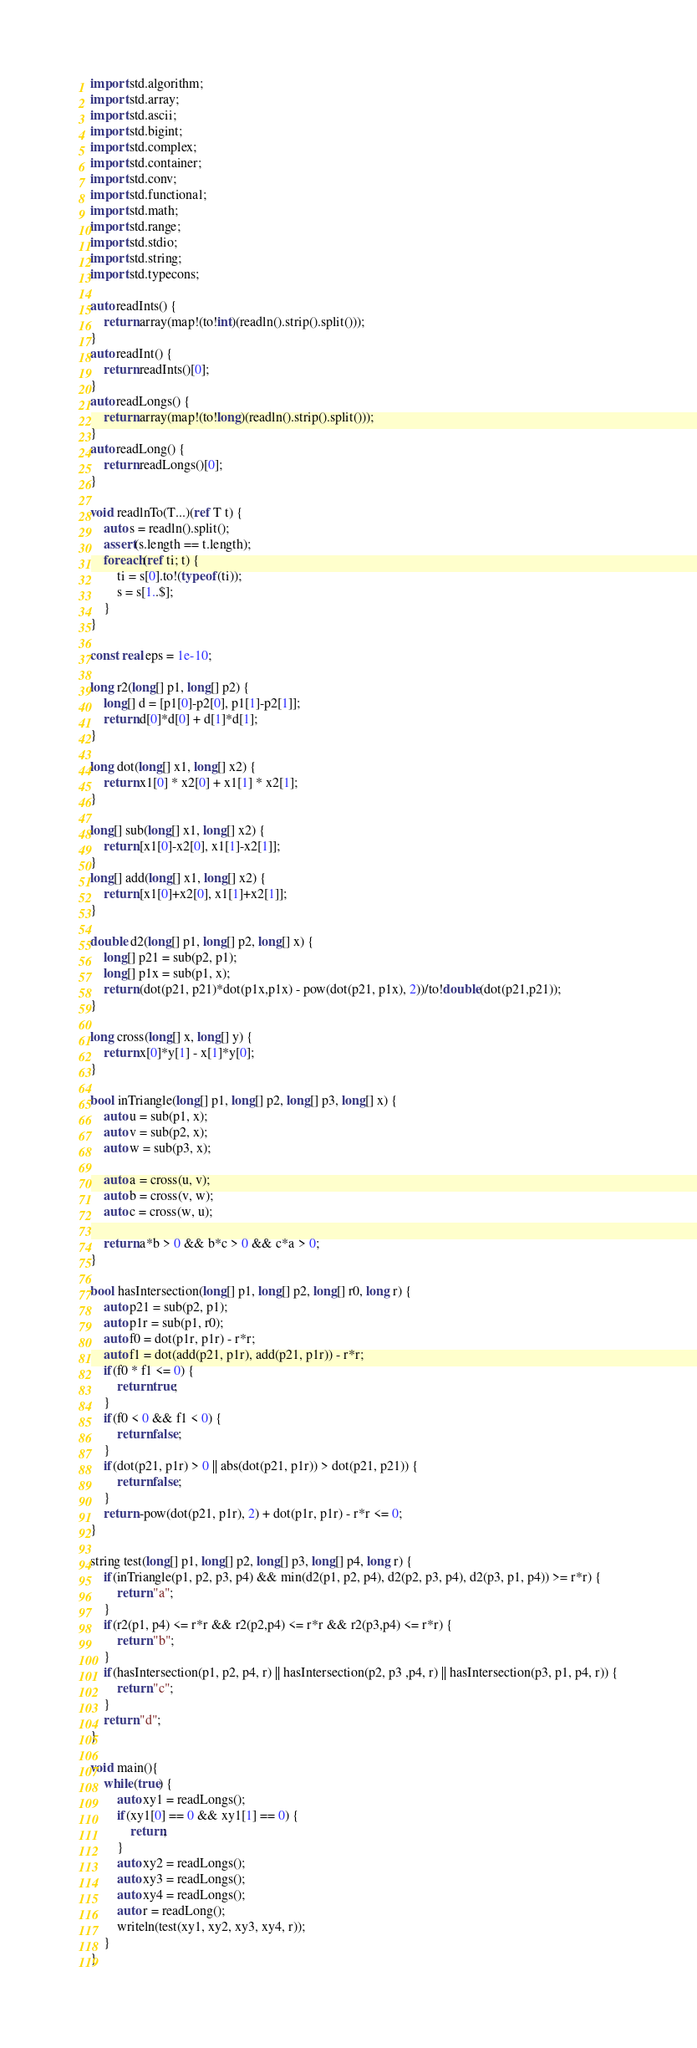Convert code to text. <code><loc_0><loc_0><loc_500><loc_500><_D_>import std.algorithm;
import std.array;
import std.ascii;
import std.bigint;
import std.complex;
import std.container;
import std.conv;
import std.functional;
import std.math;
import std.range;
import std.stdio;
import std.string;
import std.typecons;

auto readInts() {
	return array(map!(to!int)(readln().strip().split()));
}
auto readInt() {
	return readInts()[0];
}
auto readLongs() {
	return array(map!(to!long)(readln().strip().split()));
}
auto readLong() {
	return readLongs()[0];
}

void readlnTo(T...)(ref T t) {
    auto s = readln().split();
    assert(s.length == t.length);
    foreach(ref ti; t) {
        ti = s[0].to!(typeof(ti));
        s = s[1..$];
    }
}

const real eps = 1e-10;

long r2(long[] p1, long[] p2) {
    long[] d = [p1[0]-p2[0], p1[1]-p2[1]];
    return d[0]*d[0] + d[1]*d[1];
}

long dot(long[] x1, long[] x2) {
    return x1[0] * x2[0] + x1[1] * x2[1];
}

long[] sub(long[] x1, long[] x2) {
    return [x1[0]-x2[0], x1[1]-x2[1]];
}
long[] add(long[] x1, long[] x2) {
    return [x1[0]+x2[0], x1[1]+x2[1]];
}

double d2(long[] p1, long[] p2, long[] x) {
    long[] p21 = sub(p2, p1);
    long[] p1x = sub(p1, x);
    return (dot(p21, p21)*dot(p1x,p1x) - pow(dot(p21, p1x), 2))/to!double(dot(p21,p21));
}

long cross(long[] x, long[] y) {
    return x[0]*y[1] - x[1]*y[0];
}

bool inTriangle(long[] p1, long[] p2, long[] p3, long[] x) {
    auto u = sub(p1, x);
    auto v = sub(p2, x);
    auto w = sub(p3, x);
    
    auto a = cross(u, v);
    auto b = cross(v, w);
    auto c = cross(w, u);

    return a*b > 0 && b*c > 0 && c*a > 0;
}

bool hasIntersection(long[] p1, long[] p2, long[] r0, long r) {
    auto p21 = sub(p2, p1);
    auto p1r = sub(p1, r0);
    auto f0 = dot(p1r, p1r) - r*r;
    auto f1 = dot(add(p21, p1r), add(p21, p1r)) - r*r;
    if(f0 * f1 <= 0) {
        return true;
    }
    if(f0 < 0 && f1 < 0) {
        return false;
    }
    if(dot(p21, p1r) > 0 || abs(dot(p21, p1r)) > dot(p21, p21)) {
        return false;
    }
    return -pow(dot(p21, p1r), 2) + dot(p1r, p1r) - r*r <= 0;
}

string test(long[] p1, long[] p2, long[] p3, long[] p4, long r) {
    if(inTriangle(p1, p2, p3, p4) && min(d2(p1, p2, p4), d2(p2, p3, p4), d2(p3, p1, p4)) >= r*r) {
        return "a";
    }
    if(r2(p1, p4) <= r*r && r2(p2,p4) <= r*r && r2(p3,p4) <= r*r) {
        return "b";
    }
    if(hasIntersection(p1, p2, p4, r) || hasIntersection(p2, p3 ,p4, r) || hasIntersection(p3, p1, p4, r)) {
        return "c";
    }
    return "d";
}

void main(){
    while(true) {
        auto xy1 = readLongs();
        if(xy1[0] == 0 && xy1[1] == 0) {
            return;
        }
        auto xy2 = readLongs();
        auto xy3 = readLongs();
        auto xy4 = readLongs();
        auto r = readLong();
        writeln(test(xy1, xy2, xy3, xy4, r));
    }
}</code> 